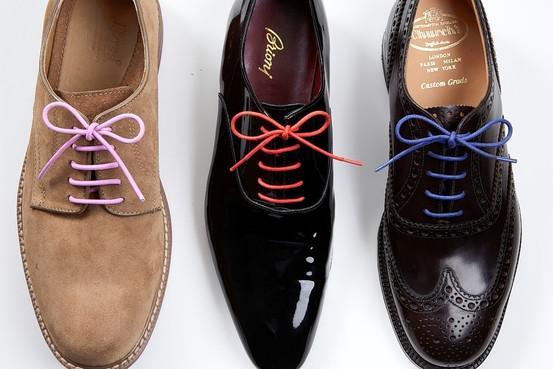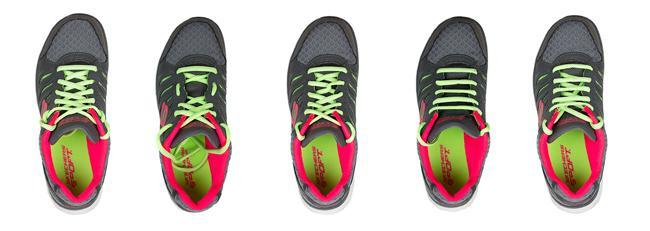The first image is the image on the left, the second image is the image on the right. For the images displayed, is the sentence "All of the shoes shown have the same color laces." factually correct? Answer yes or no. No. The first image is the image on the left, the second image is the image on the right. Given the left and right images, does the statement "There is a total of four shoes." hold true? Answer yes or no. No. 